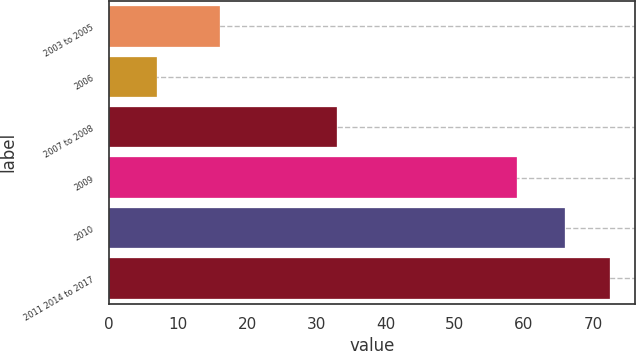Convert chart to OTSL. <chart><loc_0><loc_0><loc_500><loc_500><bar_chart><fcel>2003 to 2005<fcel>2006<fcel>2007 to 2008<fcel>2009<fcel>2010<fcel>2011 2014 to 2017<nl><fcel>16<fcel>7<fcel>33<fcel>59<fcel>66<fcel>72.5<nl></chart> 